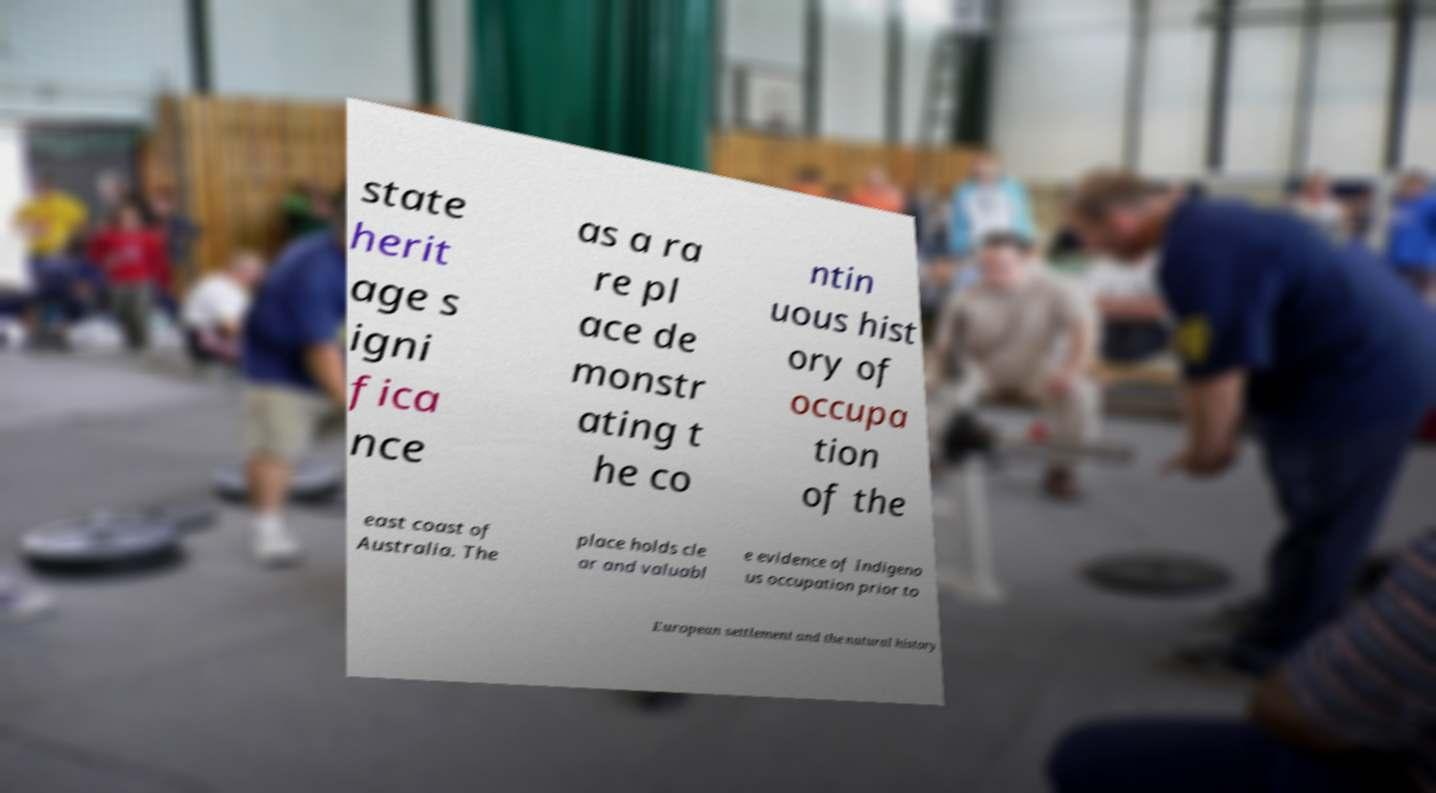What messages or text are displayed in this image? I need them in a readable, typed format. state herit age s igni fica nce as a ra re pl ace de monstr ating t he co ntin uous hist ory of occupa tion of the east coast of Australia. The place holds cle ar and valuabl e evidence of Indigeno us occupation prior to European settlement and the natural history 